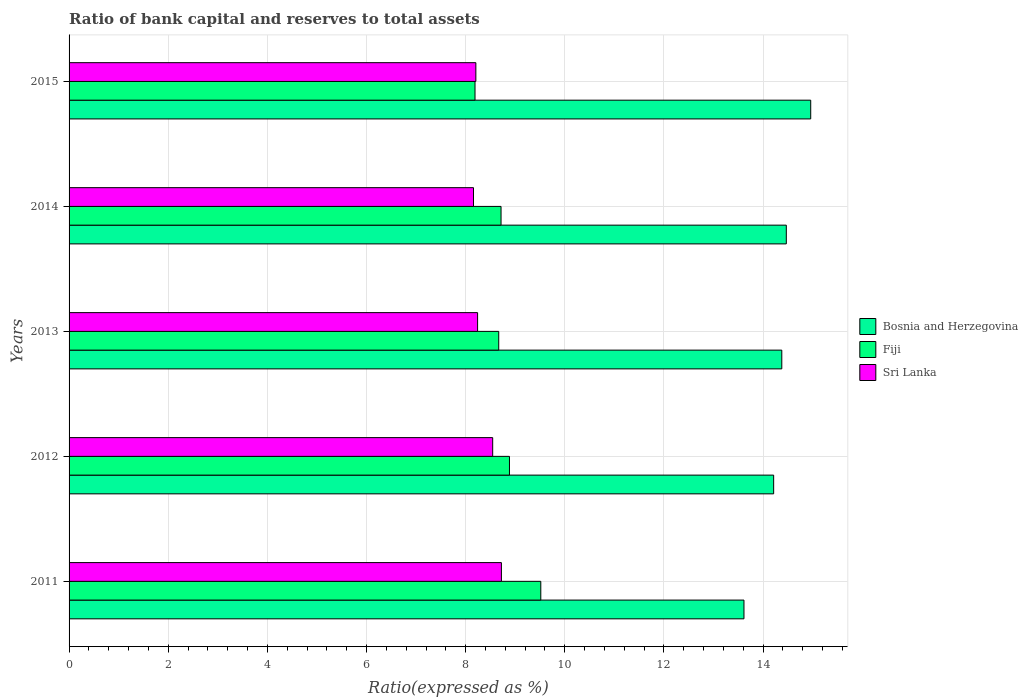Are the number of bars per tick equal to the number of legend labels?
Your response must be concise. Yes. How many bars are there on the 4th tick from the top?
Make the answer very short. 3. What is the ratio of bank capital and reserves to total assets in Sri Lanka in 2012?
Offer a terse response. 8.55. Across all years, what is the maximum ratio of bank capital and reserves to total assets in Fiji?
Offer a very short reply. 9.52. Across all years, what is the minimum ratio of bank capital and reserves to total assets in Fiji?
Your response must be concise. 8.19. In which year was the ratio of bank capital and reserves to total assets in Bosnia and Herzegovina maximum?
Keep it short and to the point. 2015. In which year was the ratio of bank capital and reserves to total assets in Fiji minimum?
Give a very brief answer. 2015. What is the total ratio of bank capital and reserves to total assets in Bosnia and Herzegovina in the graph?
Offer a very short reply. 71.63. What is the difference between the ratio of bank capital and reserves to total assets in Bosnia and Herzegovina in 2012 and that in 2015?
Make the answer very short. -0.75. What is the difference between the ratio of bank capital and reserves to total assets in Sri Lanka in 2013 and the ratio of bank capital and reserves to total assets in Bosnia and Herzegovina in 2012?
Offer a terse response. -5.97. What is the average ratio of bank capital and reserves to total assets in Bosnia and Herzegovina per year?
Provide a short and direct response. 14.33. In the year 2013, what is the difference between the ratio of bank capital and reserves to total assets in Bosnia and Herzegovina and ratio of bank capital and reserves to total assets in Sri Lanka?
Keep it short and to the point. 6.14. In how many years, is the ratio of bank capital and reserves to total assets in Bosnia and Herzegovina greater than 2.4 %?
Offer a very short reply. 5. What is the ratio of the ratio of bank capital and reserves to total assets in Fiji in 2011 to that in 2012?
Your response must be concise. 1.07. What is the difference between the highest and the second highest ratio of bank capital and reserves to total assets in Fiji?
Provide a succinct answer. 0.63. What is the difference between the highest and the lowest ratio of bank capital and reserves to total assets in Sri Lanka?
Provide a succinct answer. 0.56. In how many years, is the ratio of bank capital and reserves to total assets in Fiji greater than the average ratio of bank capital and reserves to total assets in Fiji taken over all years?
Ensure brevity in your answer.  2. Is the sum of the ratio of bank capital and reserves to total assets in Bosnia and Herzegovina in 2014 and 2015 greater than the maximum ratio of bank capital and reserves to total assets in Sri Lanka across all years?
Offer a terse response. Yes. What does the 2nd bar from the top in 2013 represents?
Offer a very short reply. Fiji. What does the 2nd bar from the bottom in 2011 represents?
Offer a very short reply. Fiji. How many bars are there?
Your response must be concise. 15. Are all the bars in the graph horizontal?
Your answer should be compact. Yes. What is the difference between two consecutive major ticks on the X-axis?
Ensure brevity in your answer.  2. Does the graph contain grids?
Ensure brevity in your answer.  Yes. How many legend labels are there?
Give a very brief answer. 3. What is the title of the graph?
Provide a short and direct response. Ratio of bank capital and reserves to total assets. What is the label or title of the X-axis?
Provide a succinct answer. Ratio(expressed as %). What is the Ratio(expressed as %) of Bosnia and Herzegovina in 2011?
Offer a terse response. 13.61. What is the Ratio(expressed as %) in Fiji in 2011?
Offer a very short reply. 9.52. What is the Ratio(expressed as %) in Sri Lanka in 2011?
Ensure brevity in your answer.  8.72. What is the Ratio(expressed as %) in Bosnia and Herzegovina in 2012?
Your response must be concise. 14.21. What is the Ratio(expressed as %) in Fiji in 2012?
Offer a terse response. 8.88. What is the Ratio(expressed as %) in Sri Lanka in 2012?
Offer a terse response. 8.55. What is the Ratio(expressed as %) in Bosnia and Herzegovina in 2013?
Your answer should be very brief. 14.38. What is the Ratio(expressed as %) in Fiji in 2013?
Your response must be concise. 8.67. What is the Ratio(expressed as %) of Sri Lanka in 2013?
Provide a succinct answer. 8.24. What is the Ratio(expressed as %) in Bosnia and Herzegovina in 2014?
Make the answer very short. 14.47. What is the Ratio(expressed as %) of Fiji in 2014?
Provide a short and direct response. 8.71. What is the Ratio(expressed as %) of Sri Lanka in 2014?
Provide a succinct answer. 8.16. What is the Ratio(expressed as %) in Bosnia and Herzegovina in 2015?
Make the answer very short. 14.96. What is the Ratio(expressed as %) of Fiji in 2015?
Provide a succinct answer. 8.19. What is the Ratio(expressed as %) of Sri Lanka in 2015?
Offer a very short reply. 8.21. Across all years, what is the maximum Ratio(expressed as %) in Bosnia and Herzegovina?
Offer a very short reply. 14.96. Across all years, what is the maximum Ratio(expressed as %) of Fiji?
Keep it short and to the point. 9.52. Across all years, what is the maximum Ratio(expressed as %) in Sri Lanka?
Your answer should be compact. 8.72. Across all years, what is the minimum Ratio(expressed as %) in Bosnia and Herzegovina?
Ensure brevity in your answer.  13.61. Across all years, what is the minimum Ratio(expressed as %) in Fiji?
Your answer should be very brief. 8.19. Across all years, what is the minimum Ratio(expressed as %) of Sri Lanka?
Offer a very short reply. 8.16. What is the total Ratio(expressed as %) of Bosnia and Herzegovina in the graph?
Provide a short and direct response. 71.63. What is the total Ratio(expressed as %) in Fiji in the graph?
Offer a very short reply. 43.97. What is the total Ratio(expressed as %) of Sri Lanka in the graph?
Make the answer very short. 41.87. What is the difference between the Ratio(expressed as %) of Bosnia and Herzegovina in 2011 and that in 2012?
Keep it short and to the point. -0.6. What is the difference between the Ratio(expressed as %) in Fiji in 2011 and that in 2012?
Make the answer very short. 0.63. What is the difference between the Ratio(expressed as %) of Sri Lanka in 2011 and that in 2012?
Your answer should be very brief. 0.18. What is the difference between the Ratio(expressed as %) of Bosnia and Herzegovina in 2011 and that in 2013?
Keep it short and to the point. -0.76. What is the difference between the Ratio(expressed as %) in Fiji in 2011 and that in 2013?
Offer a very short reply. 0.85. What is the difference between the Ratio(expressed as %) in Sri Lanka in 2011 and that in 2013?
Give a very brief answer. 0.48. What is the difference between the Ratio(expressed as %) of Bosnia and Herzegovina in 2011 and that in 2014?
Ensure brevity in your answer.  -0.85. What is the difference between the Ratio(expressed as %) in Fiji in 2011 and that in 2014?
Provide a short and direct response. 0.8. What is the difference between the Ratio(expressed as %) of Sri Lanka in 2011 and that in 2014?
Offer a terse response. 0.56. What is the difference between the Ratio(expressed as %) of Bosnia and Herzegovina in 2011 and that in 2015?
Give a very brief answer. -1.35. What is the difference between the Ratio(expressed as %) of Fiji in 2011 and that in 2015?
Provide a succinct answer. 1.33. What is the difference between the Ratio(expressed as %) in Sri Lanka in 2011 and that in 2015?
Make the answer very short. 0.52. What is the difference between the Ratio(expressed as %) in Bosnia and Herzegovina in 2012 and that in 2013?
Provide a short and direct response. -0.16. What is the difference between the Ratio(expressed as %) of Fiji in 2012 and that in 2013?
Give a very brief answer. 0.22. What is the difference between the Ratio(expressed as %) of Sri Lanka in 2012 and that in 2013?
Provide a short and direct response. 0.3. What is the difference between the Ratio(expressed as %) of Bosnia and Herzegovina in 2012 and that in 2014?
Provide a short and direct response. -0.26. What is the difference between the Ratio(expressed as %) in Fiji in 2012 and that in 2014?
Provide a succinct answer. 0.17. What is the difference between the Ratio(expressed as %) of Sri Lanka in 2012 and that in 2014?
Provide a succinct answer. 0.39. What is the difference between the Ratio(expressed as %) of Bosnia and Herzegovina in 2012 and that in 2015?
Offer a very short reply. -0.75. What is the difference between the Ratio(expressed as %) of Fiji in 2012 and that in 2015?
Make the answer very short. 0.7. What is the difference between the Ratio(expressed as %) in Sri Lanka in 2012 and that in 2015?
Offer a terse response. 0.34. What is the difference between the Ratio(expressed as %) in Bosnia and Herzegovina in 2013 and that in 2014?
Offer a very short reply. -0.09. What is the difference between the Ratio(expressed as %) of Fiji in 2013 and that in 2014?
Provide a short and direct response. -0.05. What is the difference between the Ratio(expressed as %) in Sri Lanka in 2013 and that in 2014?
Your answer should be compact. 0.08. What is the difference between the Ratio(expressed as %) in Bosnia and Herzegovina in 2013 and that in 2015?
Keep it short and to the point. -0.58. What is the difference between the Ratio(expressed as %) in Fiji in 2013 and that in 2015?
Your answer should be very brief. 0.48. What is the difference between the Ratio(expressed as %) of Sri Lanka in 2013 and that in 2015?
Your answer should be very brief. 0.04. What is the difference between the Ratio(expressed as %) in Bosnia and Herzegovina in 2014 and that in 2015?
Give a very brief answer. -0.49. What is the difference between the Ratio(expressed as %) of Fiji in 2014 and that in 2015?
Give a very brief answer. 0.53. What is the difference between the Ratio(expressed as %) in Sri Lanka in 2014 and that in 2015?
Your answer should be compact. -0.05. What is the difference between the Ratio(expressed as %) in Bosnia and Herzegovina in 2011 and the Ratio(expressed as %) in Fiji in 2012?
Your response must be concise. 4.73. What is the difference between the Ratio(expressed as %) of Bosnia and Herzegovina in 2011 and the Ratio(expressed as %) of Sri Lanka in 2012?
Make the answer very short. 5.07. What is the difference between the Ratio(expressed as %) of Fiji in 2011 and the Ratio(expressed as %) of Sri Lanka in 2012?
Make the answer very short. 0.97. What is the difference between the Ratio(expressed as %) of Bosnia and Herzegovina in 2011 and the Ratio(expressed as %) of Fiji in 2013?
Make the answer very short. 4.95. What is the difference between the Ratio(expressed as %) in Bosnia and Herzegovina in 2011 and the Ratio(expressed as %) in Sri Lanka in 2013?
Keep it short and to the point. 5.37. What is the difference between the Ratio(expressed as %) of Fiji in 2011 and the Ratio(expressed as %) of Sri Lanka in 2013?
Offer a very short reply. 1.27. What is the difference between the Ratio(expressed as %) of Bosnia and Herzegovina in 2011 and the Ratio(expressed as %) of Fiji in 2014?
Keep it short and to the point. 4.9. What is the difference between the Ratio(expressed as %) of Bosnia and Herzegovina in 2011 and the Ratio(expressed as %) of Sri Lanka in 2014?
Offer a very short reply. 5.46. What is the difference between the Ratio(expressed as %) of Fiji in 2011 and the Ratio(expressed as %) of Sri Lanka in 2014?
Offer a very short reply. 1.36. What is the difference between the Ratio(expressed as %) of Bosnia and Herzegovina in 2011 and the Ratio(expressed as %) of Fiji in 2015?
Your response must be concise. 5.43. What is the difference between the Ratio(expressed as %) in Bosnia and Herzegovina in 2011 and the Ratio(expressed as %) in Sri Lanka in 2015?
Give a very brief answer. 5.41. What is the difference between the Ratio(expressed as %) in Fiji in 2011 and the Ratio(expressed as %) in Sri Lanka in 2015?
Make the answer very short. 1.31. What is the difference between the Ratio(expressed as %) of Bosnia and Herzegovina in 2012 and the Ratio(expressed as %) of Fiji in 2013?
Make the answer very short. 5.55. What is the difference between the Ratio(expressed as %) of Bosnia and Herzegovina in 2012 and the Ratio(expressed as %) of Sri Lanka in 2013?
Provide a succinct answer. 5.97. What is the difference between the Ratio(expressed as %) in Fiji in 2012 and the Ratio(expressed as %) in Sri Lanka in 2013?
Your answer should be compact. 0.64. What is the difference between the Ratio(expressed as %) of Bosnia and Herzegovina in 2012 and the Ratio(expressed as %) of Fiji in 2014?
Keep it short and to the point. 5.5. What is the difference between the Ratio(expressed as %) in Bosnia and Herzegovina in 2012 and the Ratio(expressed as %) in Sri Lanka in 2014?
Your answer should be compact. 6.05. What is the difference between the Ratio(expressed as %) of Fiji in 2012 and the Ratio(expressed as %) of Sri Lanka in 2014?
Provide a short and direct response. 0.73. What is the difference between the Ratio(expressed as %) of Bosnia and Herzegovina in 2012 and the Ratio(expressed as %) of Fiji in 2015?
Offer a very short reply. 6.02. What is the difference between the Ratio(expressed as %) of Bosnia and Herzegovina in 2012 and the Ratio(expressed as %) of Sri Lanka in 2015?
Give a very brief answer. 6.01. What is the difference between the Ratio(expressed as %) of Fiji in 2012 and the Ratio(expressed as %) of Sri Lanka in 2015?
Your answer should be compact. 0.68. What is the difference between the Ratio(expressed as %) in Bosnia and Herzegovina in 2013 and the Ratio(expressed as %) in Fiji in 2014?
Provide a succinct answer. 5.66. What is the difference between the Ratio(expressed as %) of Bosnia and Herzegovina in 2013 and the Ratio(expressed as %) of Sri Lanka in 2014?
Give a very brief answer. 6.22. What is the difference between the Ratio(expressed as %) in Fiji in 2013 and the Ratio(expressed as %) in Sri Lanka in 2014?
Make the answer very short. 0.51. What is the difference between the Ratio(expressed as %) in Bosnia and Herzegovina in 2013 and the Ratio(expressed as %) in Fiji in 2015?
Your answer should be very brief. 6.19. What is the difference between the Ratio(expressed as %) in Bosnia and Herzegovina in 2013 and the Ratio(expressed as %) in Sri Lanka in 2015?
Offer a terse response. 6.17. What is the difference between the Ratio(expressed as %) in Fiji in 2013 and the Ratio(expressed as %) in Sri Lanka in 2015?
Keep it short and to the point. 0.46. What is the difference between the Ratio(expressed as %) of Bosnia and Herzegovina in 2014 and the Ratio(expressed as %) of Fiji in 2015?
Ensure brevity in your answer.  6.28. What is the difference between the Ratio(expressed as %) in Bosnia and Herzegovina in 2014 and the Ratio(expressed as %) in Sri Lanka in 2015?
Your answer should be compact. 6.26. What is the difference between the Ratio(expressed as %) in Fiji in 2014 and the Ratio(expressed as %) in Sri Lanka in 2015?
Give a very brief answer. 0.51. What is the average Ratio(expressed as %) in Bosnia and Herzegovina per year?
Provide a succinct answer. 14.33. What is the average Ratio(expressed as %) of Fiji per year?
Ensure brevity in your answer.  8.79. What is the average Ratio(expressed as %) in Sri Lanka per year?
Offer a terse response. 8.37. In the year 2011, what is the difference between the Ratio(expressed as %) of Bosnia and Herzegovina and Ratio(expressed as %) of Fiji?
Offer a very short reply. 4.1. In the year 2011, what is the difference between the Ratio(expressed as %) of Bosnia and Herzegovina and Ratio(expressed as %) of Sri Lanka?
Offer a very short reply. 4.89. In the year 2011, what is the difference between the Ratio(expressed as %) in Fiji and Ratio(expressed as %) in Sri Lanka?
Ensure brevity in your answer.  0.79. In the year 2012, what is the difference between the Ratio(expressed as %) in Bosnia and Herzegovina and Ratio(expressed as %) in Fiji?
Offer a very short reply. 5.33. In the year 2012, what is the difference between the Ratio(expressed as %) of Bosnia and Herzegovina and Ratio(expressed as %) of Sri Lanka?
Your response must be concise. 5.67. In the year 2012, what is the difference between the Ratio(expressed as %) of Fiji and Ratio(expressed as %) of Sri Lanka?
Provide a succinct answer. 0.34. In the year 2013, what is the difference between the Ratio(expressed as %) of Bosnia and Herzegovina and Ratio(expressed as %) of Fiji?
Make the answer very short. 5.71. In the year 2013, what is the difference between the Ratio(expressed as %) in Bosnia and Herzegovina and Ratio(expressed as %) in Sri Lanka?
Make the answer very short. 6.14. In the year 2013, what is the difference between the Ratio(expressed as %) in Fiji and Ratio(expressed as %) in Sri Lanka?
Your answer should be very brief. 0.43. In the year 2014, what is the difference between the Ratio(expressed as %) of Bosnia and Herzegovina and Ratio(expressed as %) of Fiji?
Give a very brief answer. 5.75. In the year 2014, what is the difference between the Ratio(expressed as %) in Bosnia and Herzegovina and Ratio(expressed as %) in Sri Lanka?
Provide a succinct answer. 6.31. In the year 2014, what is the difference between the Ratio(expressed as %) in Fiji and Ratio(expressed as %) in Sri Lanka?
Keep it short and to the point. 0.56. In the year 2015, what is the difference between the Ratio(expressed as %) in Bosnia and Herzegovina and Ratio(expressed as %) in Fiji?
Offer a very short reply. 6.77. In the year 2015, what is the difference between the Ratio(expressed as %) in Bosnia and Herzegovina and Ratio(expressed as %) in Sri Lanka?
Give a very brief answer. 6.76. In the year 2015, what is the difference between the Ratio(expressed as %) in Fiji and Ratio(expressed as %) in Sri Lanka?
Make the answer very short. -0.02. What is the ratio of the Ratio(expressed as %) of Bosnia and Herzegovina in 2011 to that in 2012?
Give a very brief answer. 0.96. What is the ratio of the Ratio(expressed as %) of Fiji in 2011 to that in 2012?
Make the answer very short. 1.07. What is the ratio of the Ratio(expressed as %) of Sri Lanka in 2011 to that in 2012?
Provide a succinct answer. 1.02. What is the ratio of the Ratio(expressed as %) in Bosnia and Herzegovina in 2011 to that in 2013?
Your response must be concise. 0.95. What is the ratio of the Ratio(expressed as %) of Fiji in 2011 to that in 2013?
Give a very brief answer. 1.1. What is the ratio of the Ratio(expressed as %) in Sri Lanka in 2011 to that in 2013?
Your response must be concise. 1.06. What is the ratio of the Ratio(expressed as %) in Bosnia and Herzegovina in 2011 to that in 2014?
Your answer should be very brief. 0.94. What is the ratio of the Ratio(expressed as %) of Fiji in 2011 to that in 2014?
Your response must be concise. 1.09. What is the ratio of the Ratio(expressed as %) of Sri Lanka in 2011 to that in 2014?
Your answer should be very brief. 1.07. What is the ratio of the Ratio(expressed as %) in Bosnia and Herzegovina in 2011 to that in 2015?
Ensure brevity in your answer.  0.91. What is the ratio of the Ratio(expressed as %) of Fiji in 2011 to that in 2015?
Offer a terse response. 1.16. What is the ratio of the Ratio(expressed as %) in Sri Lanka in 2011 to that in 2015?
Offer a very short reply. 1.06. What is the ratio of the Ratio(expressed as %) of Fiji in 2012 to that in 2013?
Keep it short and to the point. 1.02. What is the ratio of the Ratio(expressed as %) in Sri Lanka in 2012 to that in 2013?
Offer a very short reply. 1.04. What is the ratio of the Ratio(expressed as %) of Bosnia and Herzegovina in 2012 to that in 2014?
Your answer should be very brief. 0.98. What is the ratio of the Ratio(expressed as %) of Fiji in 2012 to that in 2014?
Your response must be concise. 1.02. What is the ratio of the Ratio(expressed as %) in Sri Lanka in 2012 to that in 2014?
Provide a succinct answer. 1.05. What is the ratio of the Ratio(expressed as %) in Fiji in 2012 to that in 2015?
Offer a very short reply. 1.08. What is the ratio of the Ratio(expressed as %) in Sri Lanka in 2012 to that in 2015?
Your answer should be compact. 1.04. What is the ratio of the Ratio(expressed as %) of Bosnia and Herzegovina in 2013 to that in 2014?
Give a very brief answer. 0.99. What is the ratio of the Ratio(expressed as %) of Fiji in 2013 to that in 2015?
Your response must be concise. 1.06. What is the ratio of the Ratio(expressed as %) of Sri Lanka in 2013 to that in 2015?
Give a very brief answer. 1. What is the ratio of the Ratio(expressed as %) of Bosnia and Herzegovina in 2014 to that in 2015?
Your response must be concise. 0.97. What is the ratio of the Ratio(expressed as %) in Fiji in 2014 to that in 2015?
Your answer should be compact. 1.06. What is the difference between the highest and the second highest Ratio(expressed as %) of Bosnia and Herzegovina?
Make the answer very short. 0.49. What is the difference between the highest and the second highest Ratio(expressed as %) of Fiji?
Give a very brief answer. 0.63. What is the difference between the highest and the second highest Ratio(expressed as %) in Sri Lanka?
Ensure brevity in your answer.  0.18. What is the difference between the highest and the lowest Ratio(expressed as %) in Bosnia and Herzegovina?
Provide a short and direct response. 1.35. What is the difference between the highest and the lowest Ratio(expressed as %) in Fiji?
Provide a succinct answer. 1.33. What is the difference between the highest and the lowest Ratio(expressed as %) of Sri Lanka?
Give a very brief answer. 0.56. 